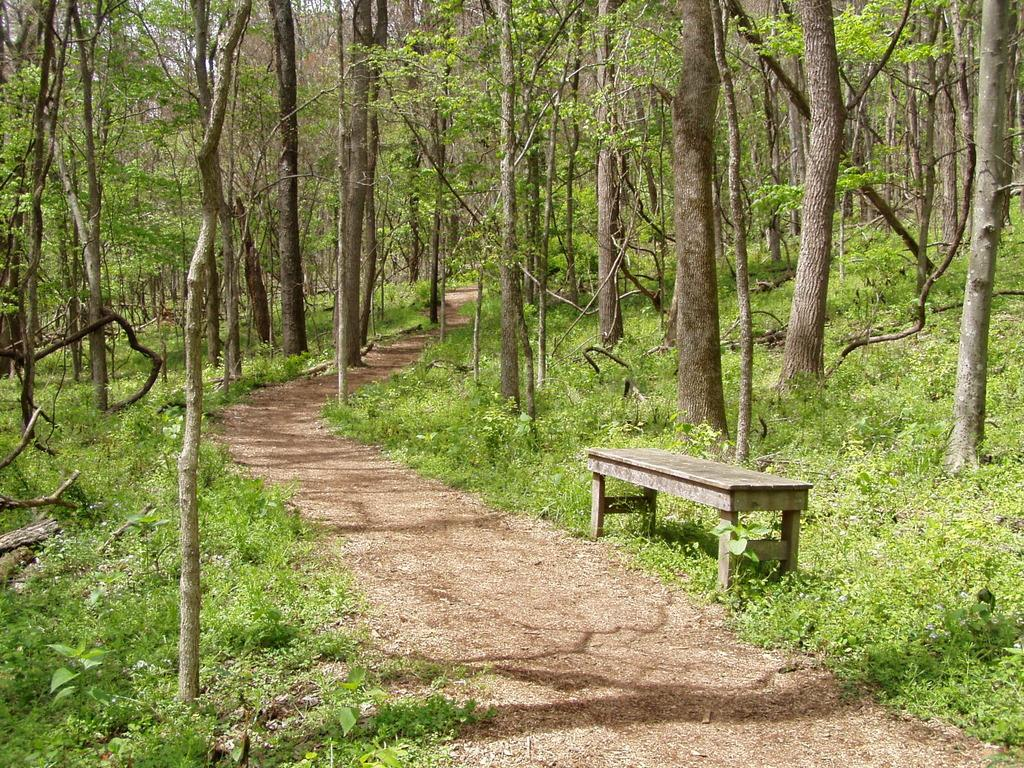What type of vegetation can be seen in the image? There are trees in the image. What type of seating is available in the image? There is a bench on the side in the image. What is present on the ground in the image? There are plants on the ground in the image. What can be used for walking or traversing the area in the image? There is a path visible in the image. Can you see any cords attached to the trees in the image? There are no cords visible in the image; it only features trees, a bench, plants, and a path. What type of lawyer is sitting on the bench in the image? There is no lawyer present in the image; it only features trees, a bench, plants, and a path. 